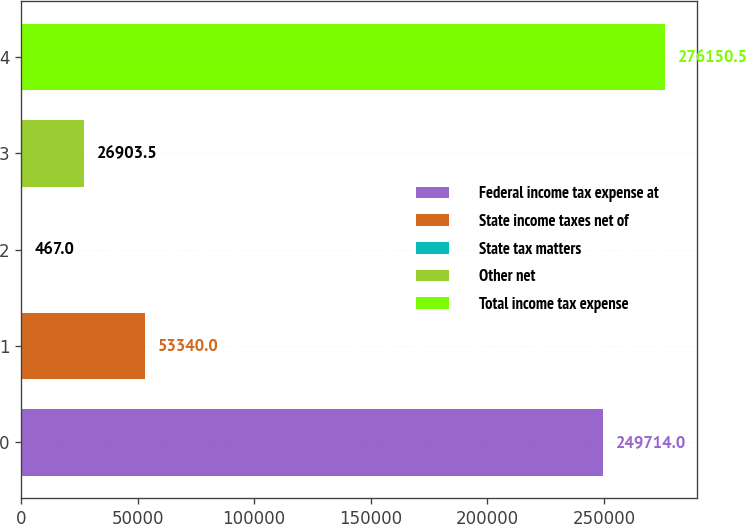Convert chart. <chart><loc_0><loc_0><loc_500><loc_500><bar_chart><fcel>Federal income tax expense at<fcel>State income taxes net of<fcel>State tax matters<fcel>Other net<fcel>Total income tax expense<nl><fcel>249714<fcel>53340<fcel>467<fcel>26903.5<fcel>276150<nl></chart> 